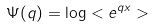Convert formula to latex. <formula><loc_0><loc_0><loc_500><loc_500>\Psi ( q ) = \log < e ^ { q x } ></formula> 